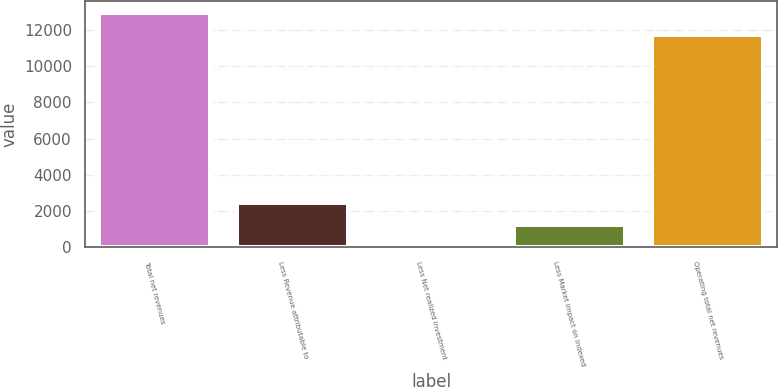Convert chart. <chart><loc_0><loc_0><loc_500><loc_500><bar_chart><fcel>Total net revenues<fcel>Less Revenue attributable to<fcel>Less Net realized investment<fcel>Less Market impact on indexed<fcel>Operating total net revenues<nl><fcel>12950.6<fcel>2437.2<fcel>4<fcel>1220.6<fcel>11734<nl></chart> 